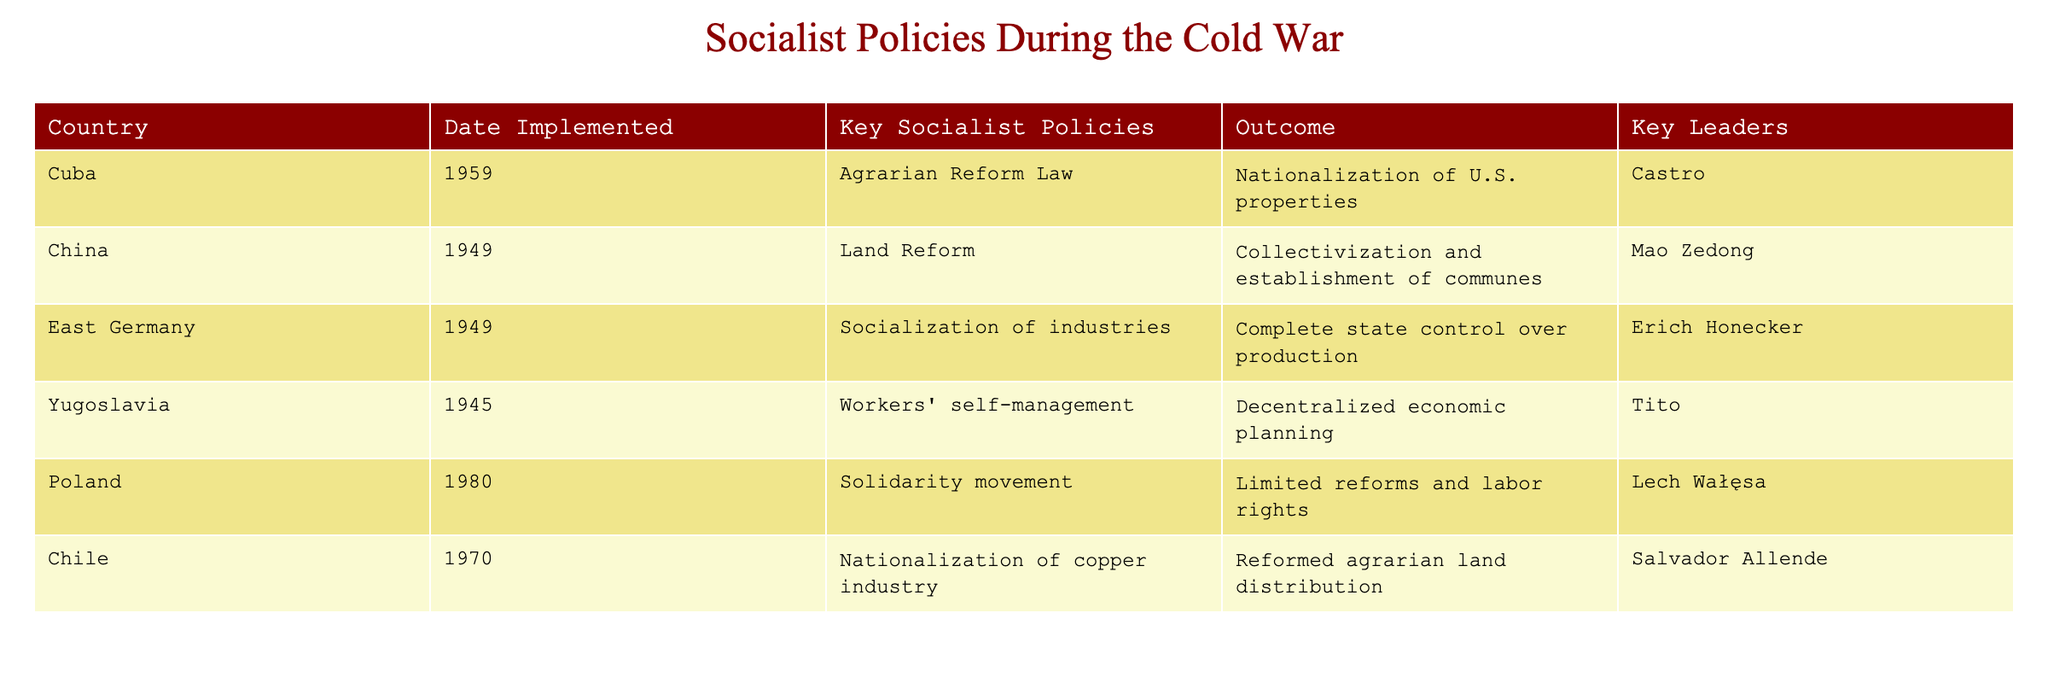What country implemented socialist policies first? The table lists countries along with the date they implemented their socialist policies. By examining the "Date Implemented" column, I see that China in 1949 is the earliest entry, while the other countries implemented theirs later.
Answer: China What was the key socialist policy of Cuba? From the "Key Socialist Policies" column, it shows that Cuba implemented the "Agrarian Reform Law" as its key socialist policy.
Answer: Agrarian Reform Law Which country had the outcome of "Complete state control over production"? By looking at the "Outcome" column, the entry that corresponds to "Complete state control over production" is linked to East Germany.
Answer: East Germany How many countries had policies related to labor rights? I can identify entries by looking through the "Outcome" column for any mention of labor rights. The countries showing reference to labor rights are Poland (limited reforms) and indirectly, Cuba (nationalization involved labor). Counting these gives us two countries.
Answer: 2 Did Yugoslavia nationalize any key industries? By checking the "Key Socialist Policies" for Yugoslavia, it mentions "Workers' self-management" which implies decentralization rather than direct nationalization like others. Therefore, the answer is no, they did not nationalize key industries.
Answer: No Which country exhibited decentralization in its socialist policy? The table lists "Workers' self-management" under Yugoslavia's key socialist policies, indicating a decentralized approach to economic planning.
Answer: Yugoslavia What was the general outcome of socialist policies in Chile? By reviewing the "Outcome" column associated with Chile, it states the outcome was "Reformed agrarian land distribution," indicating reforms rather than a strictly socialist outcome in terms of nationalization.
Answer: Reformed agrarian land distribution Which country was characterized by collectivization and establishment of communes? Looking at the "Key Socialist Policies" for China, it mentions "Collectivization and establishment of communes," directly answering the question.
Answer: China What combination of leaders and countries reflects significant socialist policies during the Cold War? Analyzing the "Key Leaders" with their corresponding countries reveals a variety but specifically, Castro with Cuba for notable revolutionary outcomes signifies a key linkage.
Answer: Castro and Cuba 